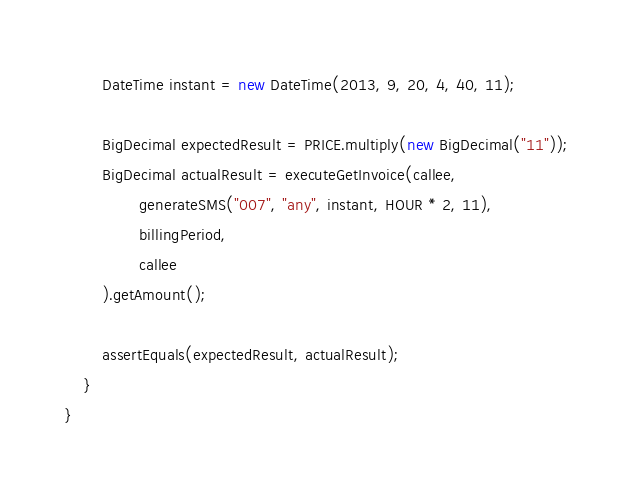Convert code to text. <code><loc_0><loc_0><loc_500><loc_500><_Java_>        DateTime instant = new DateTime(2013, 9, 20, 4, 40, 11);

        BigDecimal expectedResult = PRICE.multiply(new BigDecimal("11"));
        BigDecimal actualResult = executeGetInvoice(callee,
                generateSMS("007", "any", instant, HOUR * 2, 11),
                billingPeriod,
                callee
        ).getAmount();

        assertEquals(expectedResult, actualResult);
    }
}
</code> 